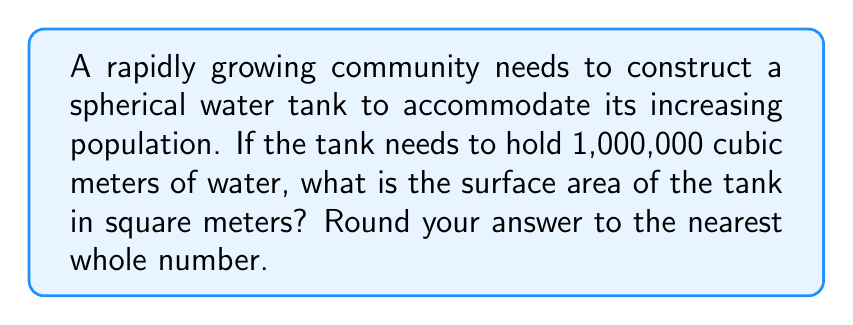Give your solution to this math problem. Let's approach this step-by-step:

1) First, we need to find the radius of the spherical tank. We know the volume, so we can use the formula for the volume of a sphere:

   $$V = \frac{4}{3}\pi r^3$$

   Where $V$ is the volume and $r$ is the radius.

2) We're given that $V = 1,000,000 \text{ m}^3$. Let's substitute this:

   $$1,000,000 = \frac{4}{3}\pi r^3$$

3) Now, let's solve for $r$:

   $$r^3 = \frac{1,000,000 \cdot 3}{4\pi}$$
   
   $$r = \sqrt[3]{\frac{1,000,000 \cdot 3}{4\pi}} \approx 62.0355 \text{ m}$$

4) Now that we have the radius, we can calculate the surface area using the formula:

   $$A = 4\pi r^2$$

5) Let's substitute our value for $r$:

   $$A = 4\pi (62.0355)^2 \approx 48,305.9 \text{ m}^2$$

6) Rounding to the nearest whole number:

   $$A \approx 48,306 \text{ m}^2$$
Answer: 48,306 $\text{m}^2$ 